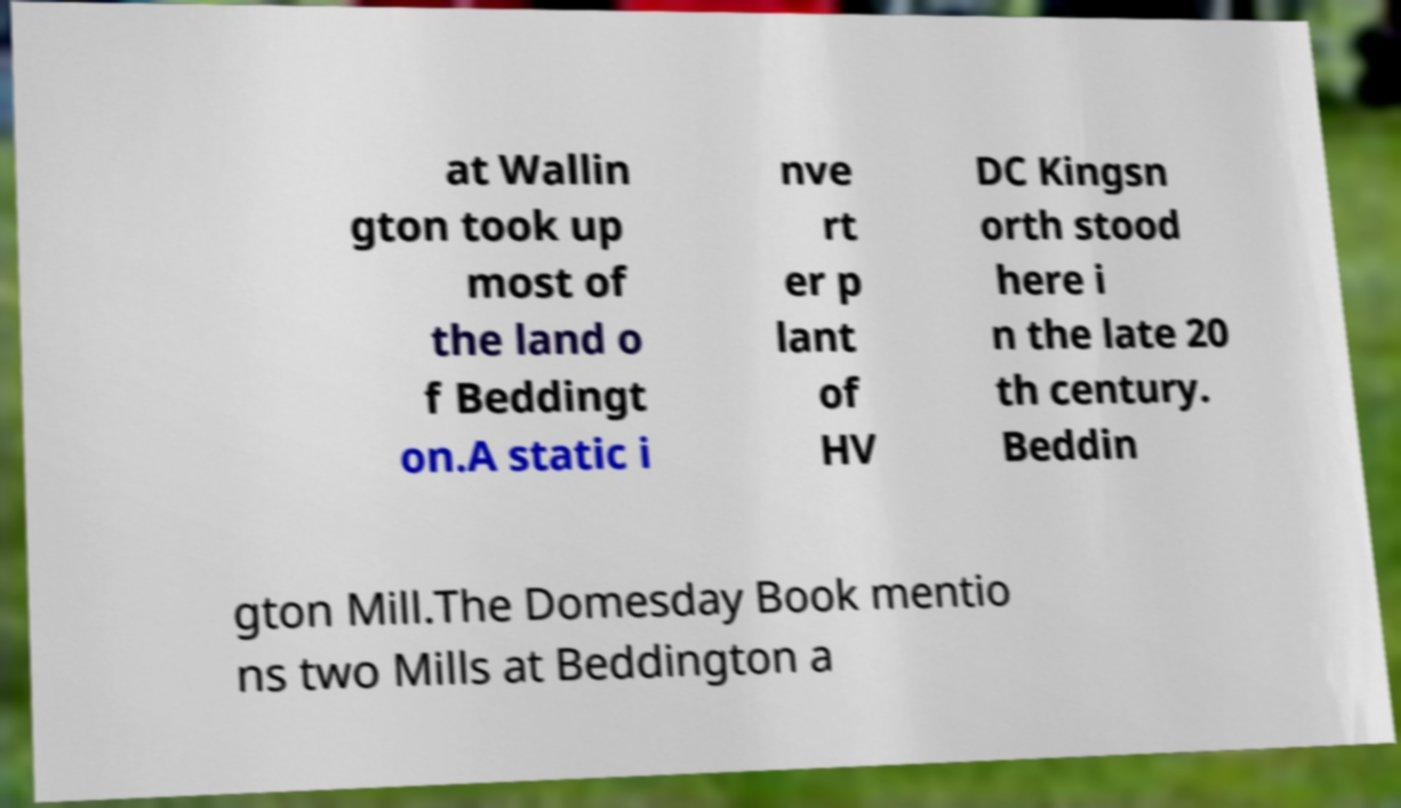I need the written content from this picture converted into text. Can you do that? at Wallin gton took up most of the land o f Beddingt on.A static i nve rt er p lant of HV DC Kingsn orth stood here i n the late 20 th century. Beddin gton Mill.The Domesday Book mentio ns two Mills at Beddington a 